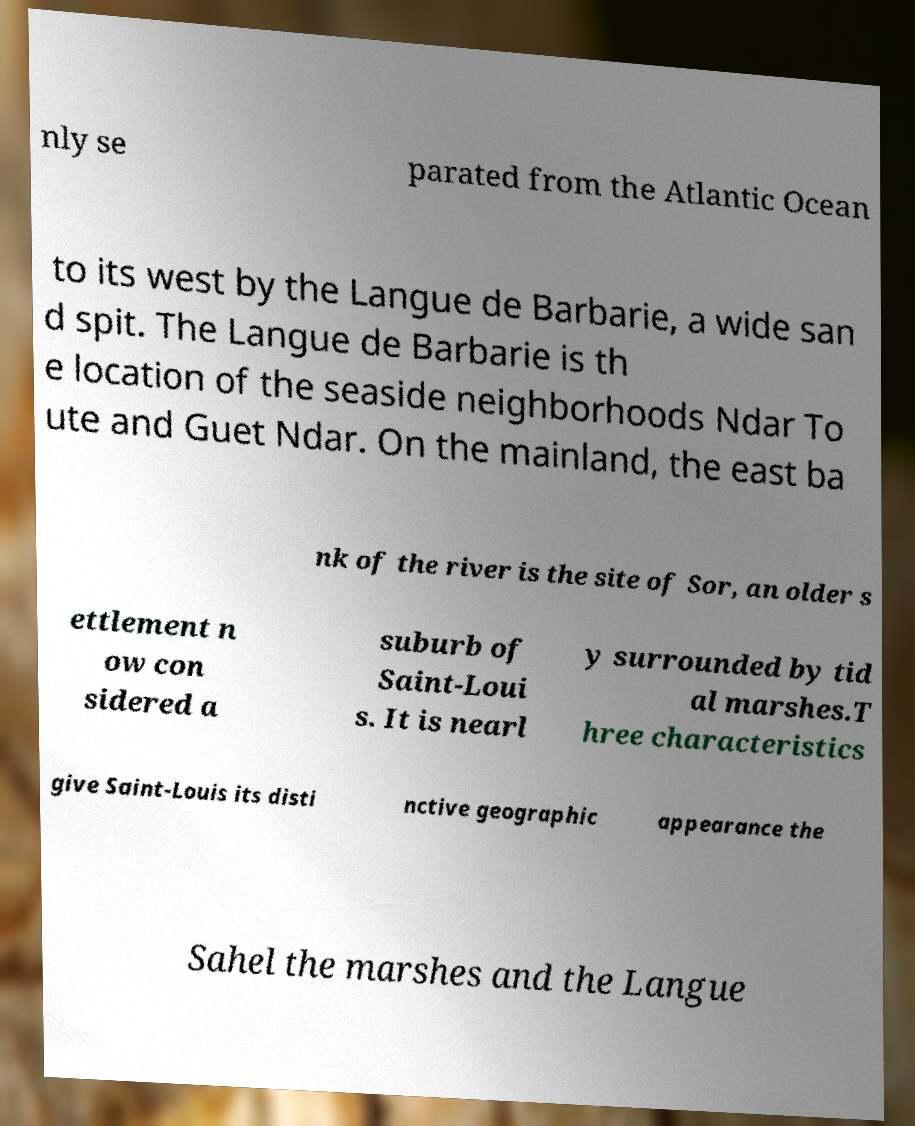I need the written content from this picture converted into text. Can you do that? nly se parated from the Atlantic Ocean to its west by the Langue de Barbarie, a wide san d spit. The Langue de Barbarie is th e location of the seaside neighborhoods Ndar To ute and Guet Ndar. On the mainland, the east ba nk of the river is the site of Sor, an older s ettlement n ow con sidered a suburb of Saint-Loui s. It is nearl y surrounded by tid al marshes.T hree characteristics give Saint-Louis its disti nctive geographic appearance the Sahel the marshes and the Langue 